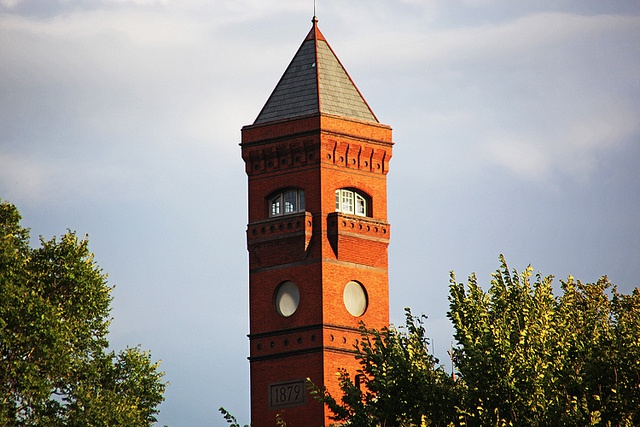Describe the objects in this image and their specific colors. I can see various objects in this image with different colors. 